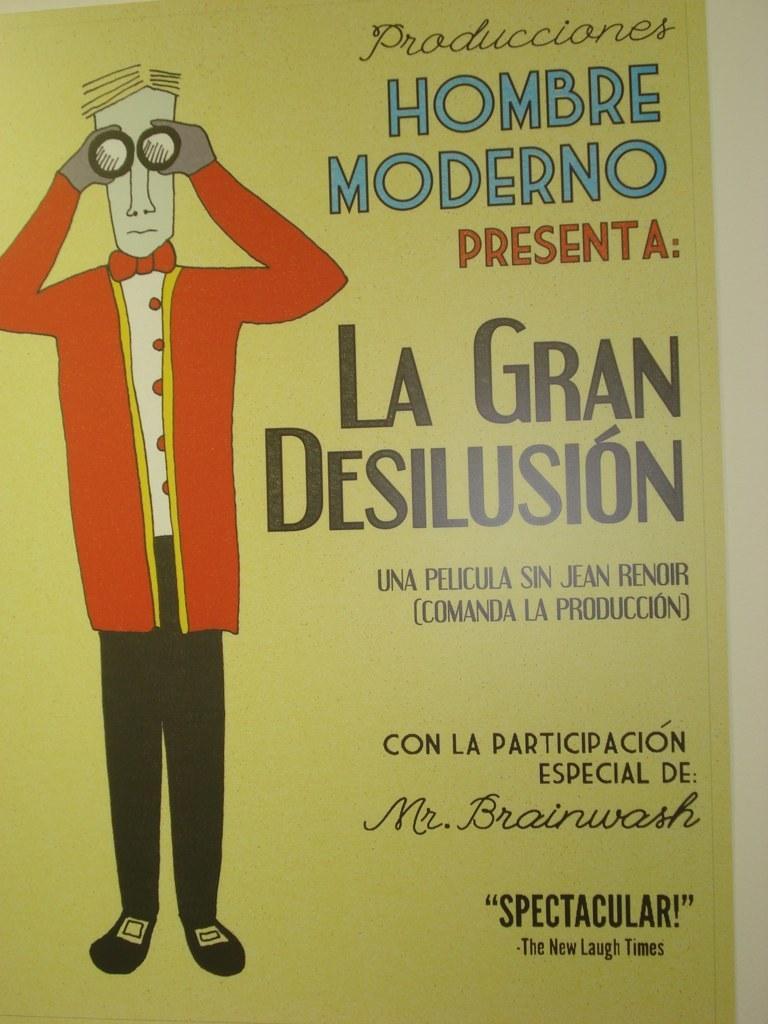Can you describe this image briefly? In this picture I can see a poster, there is a picture of a person and there are words on the poster. 